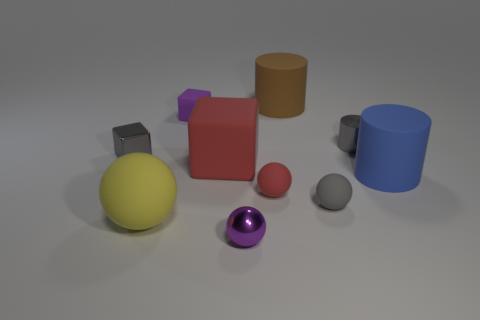Subtract all spheres. How many objects are left? 6 Add 7 tiny red rubber balls. How many tiny red rubber balls exist? 8 Subtract 1 purple blocks. How many objects are left? 9 Subtract all small purple matte objects. Subtract all large yellow balls. How many objects are left? 8 Add 2 red spheres. How many red spheres are left? 3 